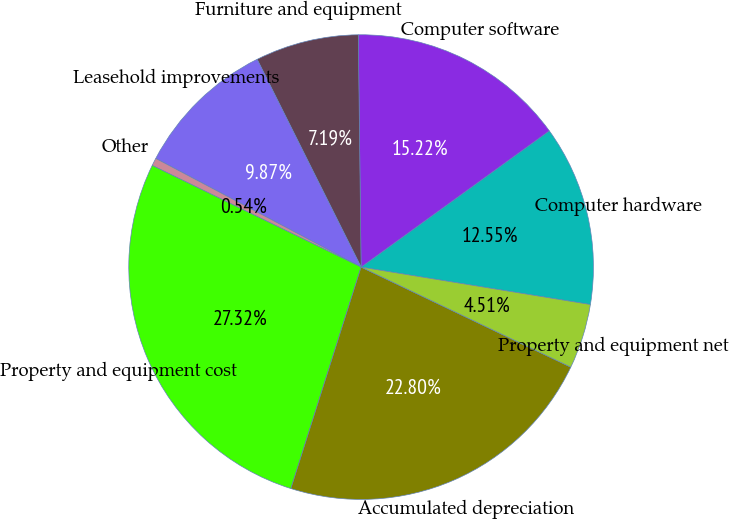Convert chart. <chart><loc_0><loc_0><loc_500><loc_500><pie_chart><fcel>Computer hardware<fcel>Computer software<fcel>Furniture and equipment<fcel>Leasehold improvements<fcel>Other<fcel>Property and equipment cost<fcel>Accumulated depreciation<fcel>Property and equipment net<nl><fcel>12.55%<fcel>15.22%<fcel>7.19%<fcel>9.87%<fcel>0.54%<fcel>27.32%<fcel>22.8%<fcel>4.51%<nl></chart> 